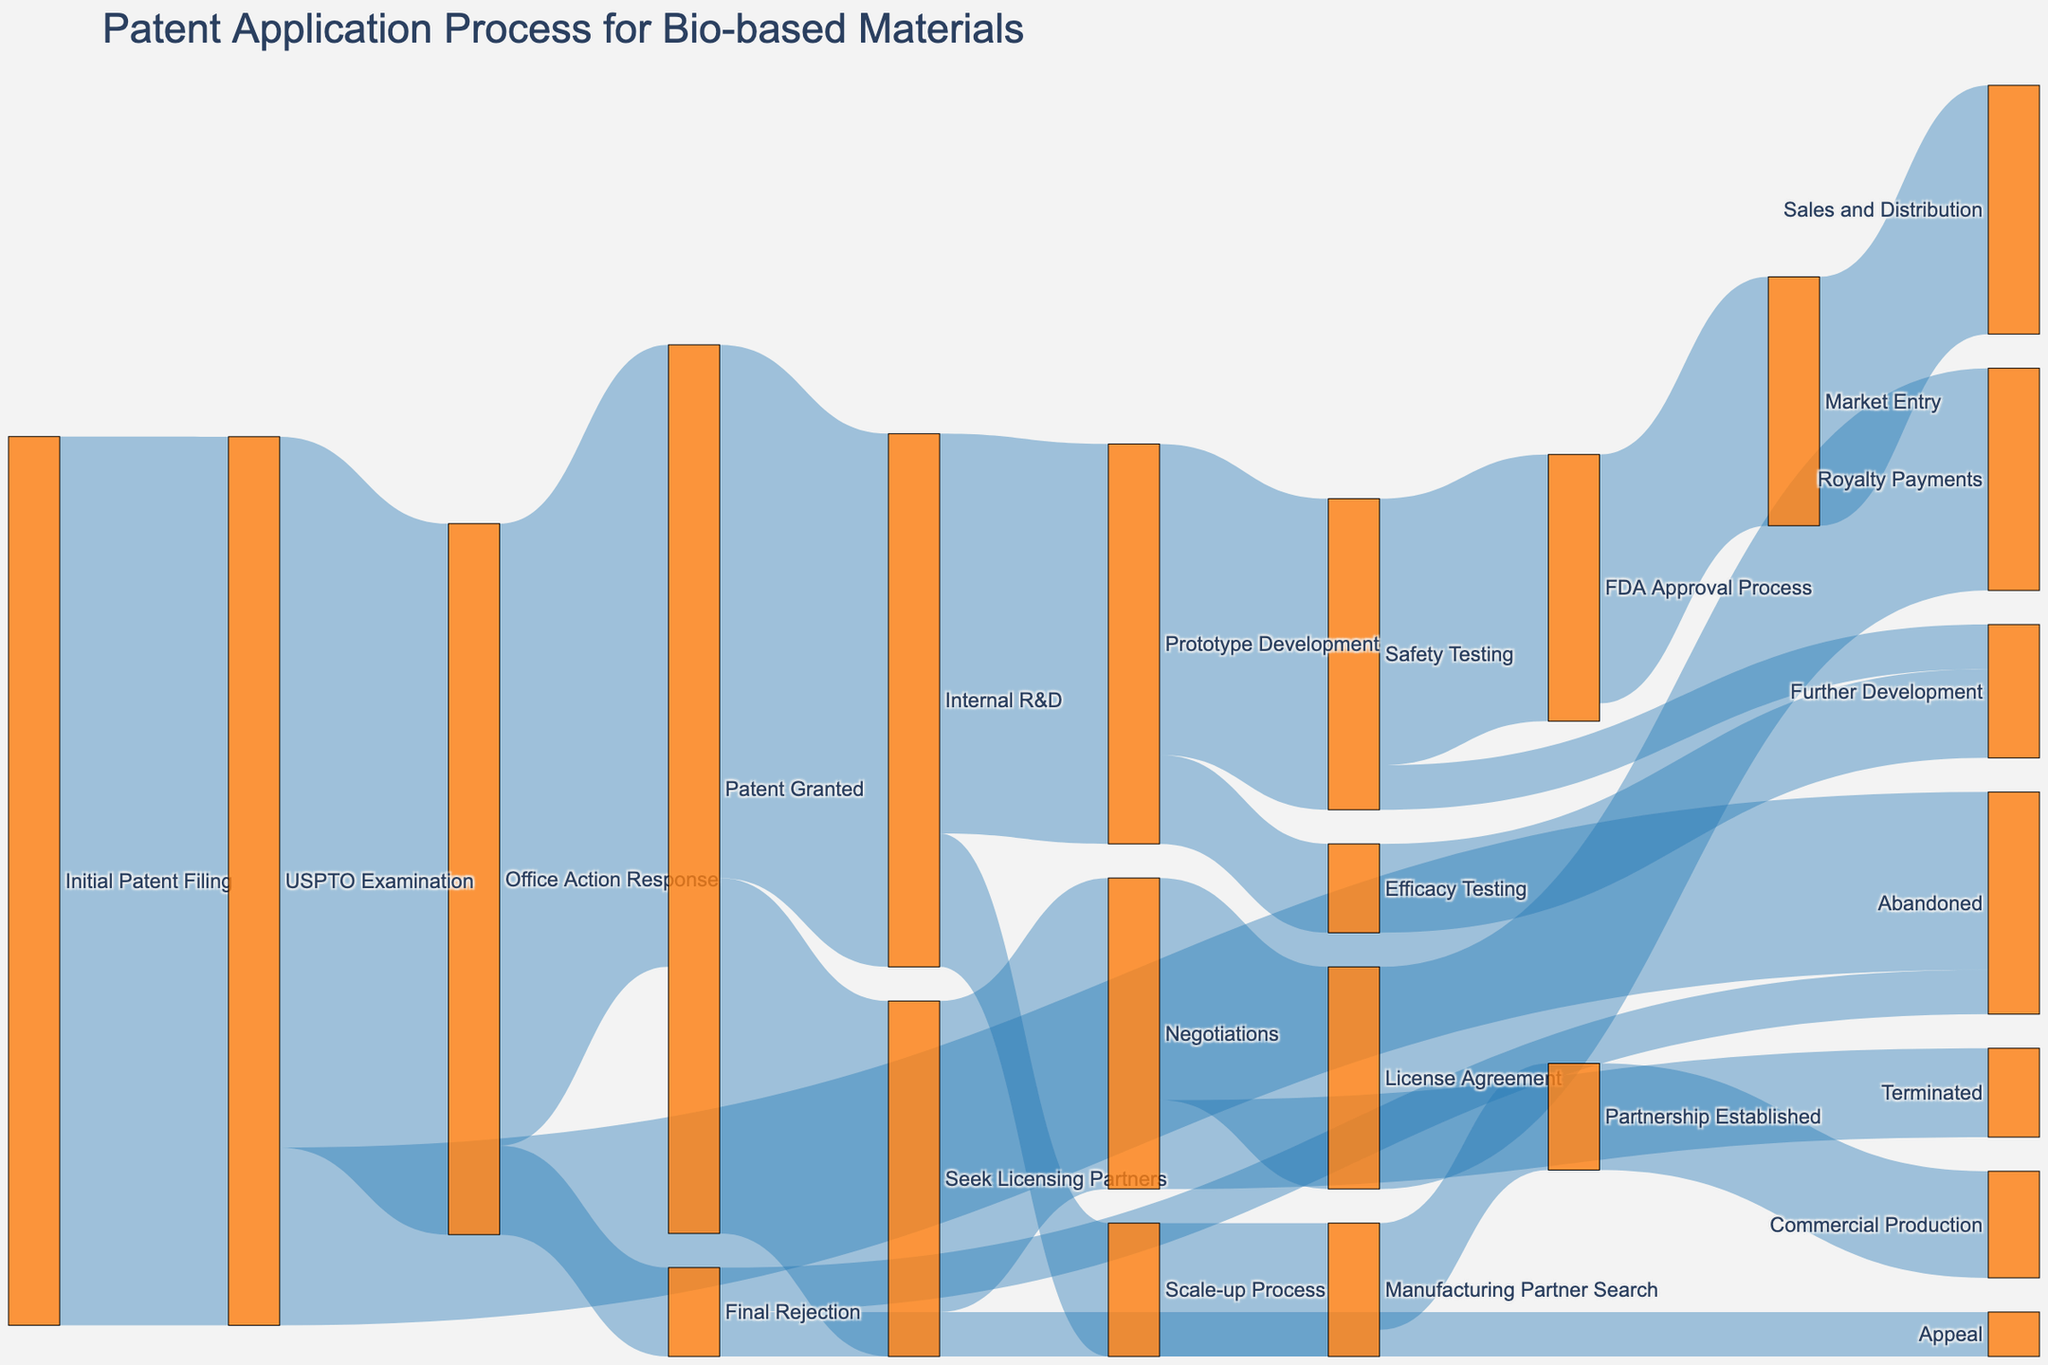What is the title of the Sankey diagram? The title of the diagram is usually located at the top, providing an overview of what the diagram is about. In this diagram, the title specifies the process it visualizes.
Answer: Patent Application Process for Bio-based Materials How many initial patent filings move to USPTO Examination? The Sankey diagram shows the flow's width representing numeric values. By looking at the "Initial Patent Filing" to "USPTO Examination" link, we can see the value.
Answer: 100 From the USPTO Examination stage, what fraction gets abandoned? First, locate the flows coming out of "USPTO Examination." The total moving from this stage is 100 (80 to "Office Action Response" and 20 to "Abandoned"). The number abandoned is 20 out of 100, so the fraction is 20/100.
Answer: 0.2 or 20% What are the two possible outcomes after Patent Granted? The Sankey diagram shows two flows extending from "Patent Granted" to other nodes. These nodes reflect the possible outcomes.
Answer: Internal R&D, Seek Licensing Partners How many patents go from Office Action Response to Final Rejection and then to Appeal? Follow the flow from "Office Action Response" to "Final Rejection" and then from "Final Rejection" to "Appeal." The values are 10 and 5, respectively.
Answer: 5 What is the value of patents that reach Commercial Production from Safety Testing? Add up the flow values through connected stages from "Safety Testing" leading to "FDA Approval Process," "Market Entry," and finally, "Sales and Distribution." Working through the stages, this path shows 30 moving through each connected node.
Answer: 28 What percentage of patents seeks licensing partners after being granted? Locate the flow from "Patent Granted" to "Seek Licensing Partners," and the total number of granted patents. The flow value to "Seek Licensing Partners" is 40. To find the percentage, divide 40 by 70 (total patents granted), then multiply by 100.
Answer: ~57.14% Compare the number of patents that reach Negotiations versus Commercial Production. First, identify the flow ending at "Negotiations" and "Commercial Production." Negotiations have a flow value of 35, and Commercial Production has a flow value of 12 from "Partnership Established."
Answer: Negotiations = 35, Commercial Production = 12 What happens to patents after they go through Prototype Development's Safety Testing phase? Trace the flow from "Safety Testing" in "Prototype Development." From the value of the flow is 35, it splits into "FDA Approval Process" with 30 continuing and "Further Development" with 5.
Answer: FDA Approval Process, Further Development 